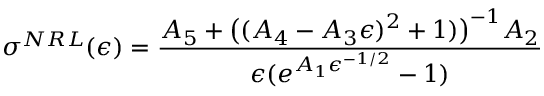<formula> <loc_0><loc_0><loc_500><loc_500>\sigma ^ { N R L } ( \epsilon ) = { \frac { A _ { 5 } + { \left ( } ( A _ { 4 } - A _ { 3 } \epsilon ) ^ { 2 } + 1 ) { \right ) } ^ { - 1 } A _ { 2 } } { \epsilon ( e ^ { A _ { 1 } \epsilon ^ { - 1 / 2 } } - 1 ) } }</formula> 